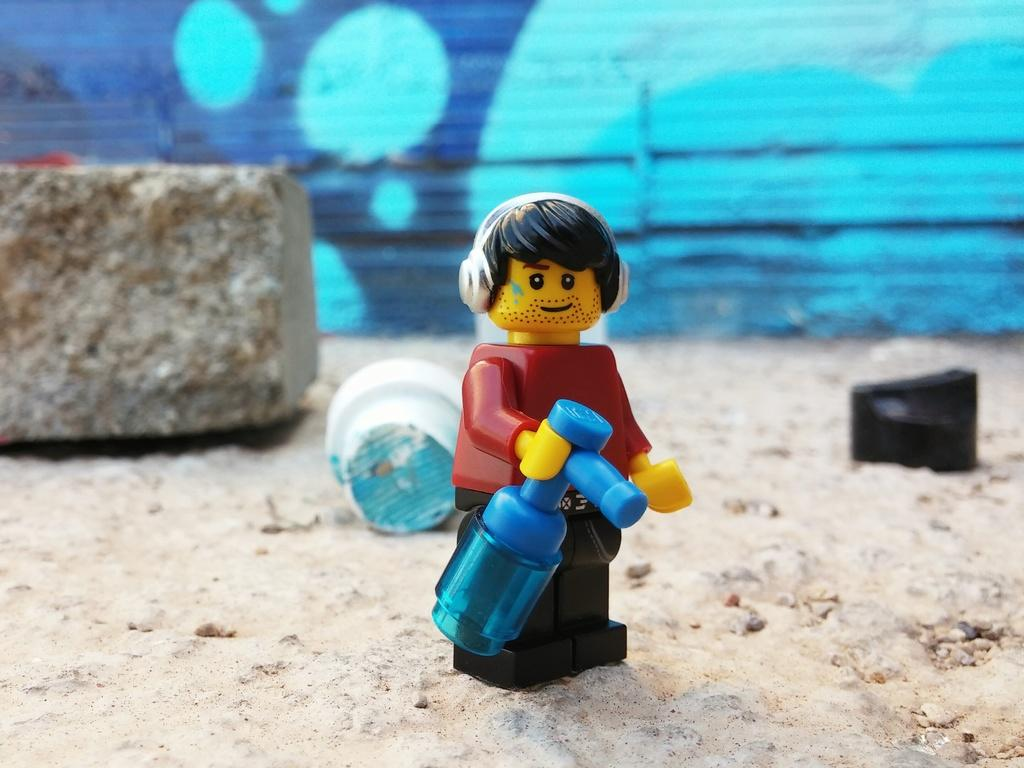What is on the ground in the image? There is a toy, other items, and a stone on the ground in the image. Can you describe the wall in the background of the image? There is a wall in the background of the image, but no specific details about the wall are provided. How many items are on the ground in the image? There are at least three items on the ground: a toy, other items, and a stone. What type of fight is happening between the toy and the stone in the image? There is no fight happening between the toy and the stone in the image; they are both inanimate objects on the ground. Can you tell me where the kettle is located in the image? There is no kettle present in the image. 